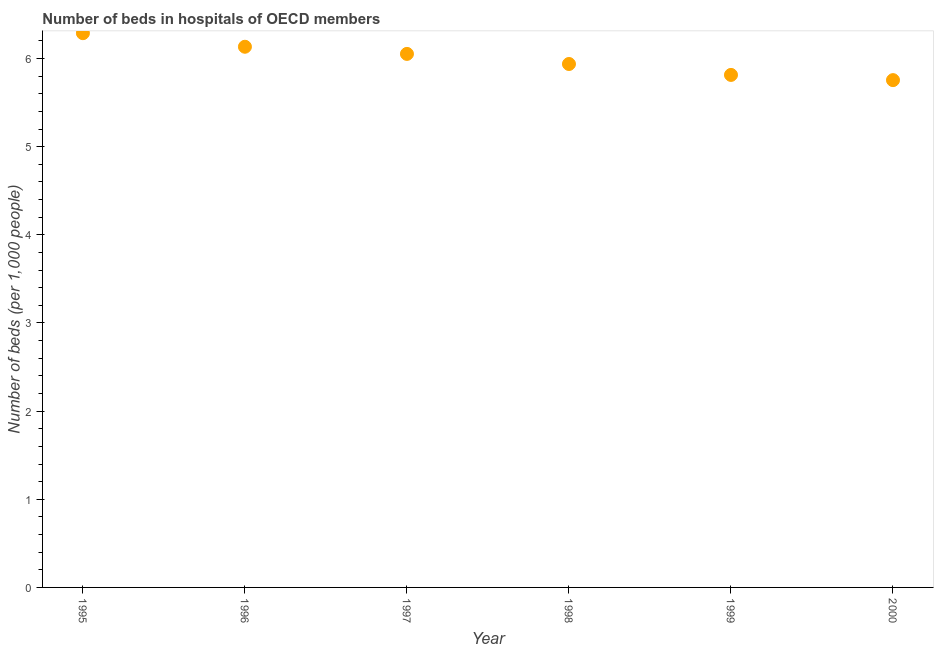What is the number of hospital beds in 1998?
Give a very brief answer. 5.94. Across all years, what is the maximum number of hospital beds?
Ensure brevity in your answer.  6.29. Across all years, what is the minimum number of hospital beds?
Provide a short and direct response. 5.76. What is the sum of the number of hospital beds?
Offer a terse response. 35.98. What is the difference between the number of hospital beds in 1997 and 1999?
Your response must be concise. 0.24. What is the average number of hospital beds per year?
Provide a succinct answer. 6. What is the median number of hospital beds?
Offer a terse response. 6. In how many years, is the number of hospital beds greater than 1.8 %?
Your answer should be compact. 6. Do a majority of the years between 1998 and 1997 (inclusive) have number of hospital beds greater than 3 %?
Offer a terse response. No. What is the ratio of the number of hospital beds in 1995 to that in 1998?
Your answer should be very brief. 1.06. Is the number of hospital beds in 1996 less than that in 1997?
Provide a succinct answer. No. What is the difference between the highest and the second highest number of hospital beds?
Provide a short and direct response. 0.15. Is the sum of the number of hospital beds in 1995 and 1996 greater than the maximum number of hospital beds across all years?
Provide a succinct answer. Yes. What is the difference between the highest and the lowest number of hospital beds?
Offer a terse response. 0.53. How many dotlines are there?
Offer a very short reply. 1. What is the difference between two consecutive major ticks on the Y-axis?
Ensure brevity in your answer.  1. Are the values on the major ticks of Y-axis written in scientific E-notation?
Your response must be concise. No. What is the title of the graph?
Offer a very short reply. Number of beds in hospitals of OECD members. What is the label or title of the Y-axis?
Make the answer very short. Number of beds (per 1,0 people). What is the Number of beds (per 1,000 people) in 1995?
Keep it short and to the point. 6.29. What is the Number of beds (per 1,000 people) in 1996?
Ensure brevity in your answer.  6.13. What is the Number of beds (per 1,000 people) in 1997?
Provide a short and direct response. 6.05. What is the Number of beds (per 1,000 people) in 1998?
Your answer should be very brief. 5.94. What is the Number of beds (per 1,000 people) in 1999?
Provide a short and direct response. 5.81. What is the Number of beds (per 1,000 people) in 2000?
Keep it short and to the point. 5.76. What is the difference between the Number of beds (per 1,000 people) in 1995 and 1996?
Provide a short and direct response. 0.15. What is the difference between the Number of beds (per 1,000 people) in 1995 and 1997?
Provide a short and direct response. 0.24. What is the difference between the Number of beds (per 1,000 people) in 1995 and 1998?
Keep it short and to the point. 0.35. What is the difference between the Number of beds (per 1,000 people) in 1995 and 1999?
Make the answer very short. 0.47. What is the difference between the Number of beds (per 1,000 people) in 1995 and 2000?
Provide a short and direct response. 0.53. What is the difference between the Number of beds (per 1,000 people) in 1996 and 1997?
Ensure brevity in your answer.  0.08. What is the difference between the Number of beds (per 1,000 people) in 1996 and 1998?
Provide a short and direct response. 0.2. What is the difference between the Number of beds (per 1,000 people) in 1996 and 1999?
Your answer should be compact. 0.32. What is the difference between the Number of beds (per 1,000 people) in 1996 and 2000?
Your answer should be compact. 0.38. What is the difference between the Number of beds (per 1,000 people) in 1997 and 1998?
Ensure brevity in your answer.  0.11. What is the difference between the Number of beds (per 1,000 people) in 1997 and 1999?
Make the answer very short. 0.24. What is the difference between the Number of beds (per 1,000 people) in 1997 and 2000?
Ensure brevity in your answer.  0.3. What is the difference between the Number of beds (per 1,000 people) in 1998 and 1999?
Provide a short and direct response. 0.12. What is the difference between the Number of beds (per 1,000 people) in 1998 and 2000?
Give a very brief answer. 0.18. What is the difference between the Number of beds (per 1,000 people) in 1999 and 2000?
Provide a succinct answer. 0.06. What is the ratio of the Number of beds (per 1,000 people) in 1995 to that in 1997?
Your answer should be compact. 1.04. What is the ratio of the Number of beds (per 1,000 people) in 1995 to that in 1998?
Keep it short and to the point. 1.06. What is the ratio of the Number of beds (per 1,000 people) in 1995 to that in 1999?
Ensure brevity in your answer.  1.08. What is the ratio of the Number of beds (per 1,000 people) in 1995 to that in 2000?
Make the answer very short. 1.09. What is the ratio of the Number of beds (per 1,000 people) in 1996 to that in 1997?
Offer a very short reply. 1.01. What is the ratio of the Number of beds (per 1,000 people) in 1996 to that in 1998?
Your response must be concise. 1.03. What is the ratio of the Number of beds (per 1,000 people) in 1996 to that in 1999?
Give a very brief answer. 1.05. What is the ratio of the Number of beds (per 1,000 people) in 1996 to that in 2000?
Make the answer very short. 1.07. What is the ratio of the Number of beds (per 1,000 people) in 1997 to that in 1998?
Offer a very short reply. 1.02. What is the ratio of the Number of beds (per 1,000 people) in 1997 to that in 1999?
Offer a very short reply. 1.04. What is the ratio of the Number of beds (per 1,000 people) in 1997 to that in 2000?
Your answer should be compact. 1.05. What is the ratio of the Number of beds (per 1,000 people) in 1998 to that in 2000?
Offer a very short reply. 1.03. What is the ratio of the Number of beds (per 1,000 people) in 1999 to that in 2000?
Ensure brevity in your answer.  1.01. 